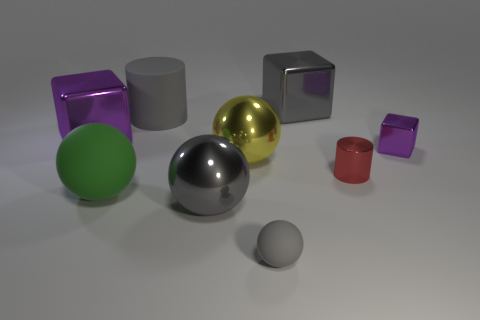Could you use these objects to explain the concept of perspective to someone? Certainly. Perspective is the way objects appear to the eye based on their spatial attributes and positions. In this image, objects of similar shape are different sizes due to their position in relation to the viewer. For example, the larger green sphere in the foreground looks bigger compared to the smaller gray sphere in the background, illustrating how objects appear smaller the further they are from the viewer, a key principle of perspective. 